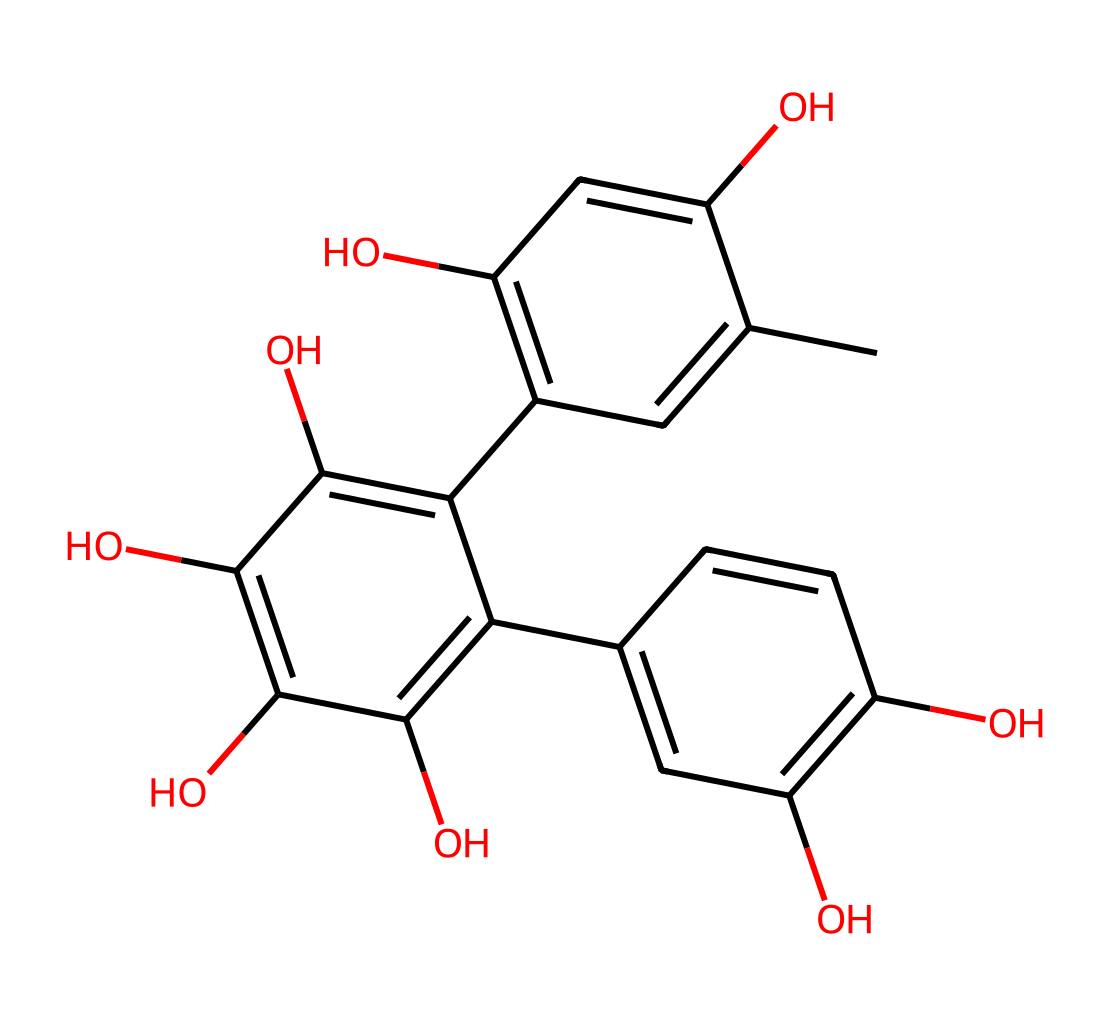What is the total number of carbon atoms in this structure? Count the carbon atoms (C) in the provided SMILES representation. Each "C" indicates a carbon atom. Upon counting, there are a total of 21 carbon atoms present in the structure.
Answer: 21 How many hydroxyl (–OH) groups are present? Identify the presence of hydroxyl groups in the chemical structure. Each "O" that is attached to a "C" within the SMILES format and is connected to hydrogen (in this case, implied by the structure) represents a hydroxyl group. There are 5 hydroxyl groups in this structure.
Answer: 5 What is the degree of unsaturation in this molecule? To determine the degree of unsaturation, use the formula: Degree of Unsaturation = C - H/2 + N/2 + 1. Here, C = 21 and H can be calculated (after counting hydrogen atoms indirectly through bonding). After calculations, the degree of unsaturation is found to be 10.
Answer: 10 Which component makes this molecule a polyphenol? The presence of multiple phenolic groups within the chemical structure, indicated by the aromatic carbon ring systems and hydroxyl groups attached to it, is what categorizes this molecule as a polyphenol.
Answer: multiple phenolic groups Is this compound primarily hydrophilic or hydrophobic? The presence of multiple hydroxyl (–OH) groups suggests that this compound has many polar sites which favor solubility in water. Therefore, it is primarily hydrophilic.
Answer: hydrophilic What role do tannins typically play in tea? Tannins are natural polyphenols that contribute to astringency and may offer antioxidant properties. This molecular structure suggests it has similar functionalities, such as affecting taste and health benefits.
Answer: astringency and antioxidant properties 